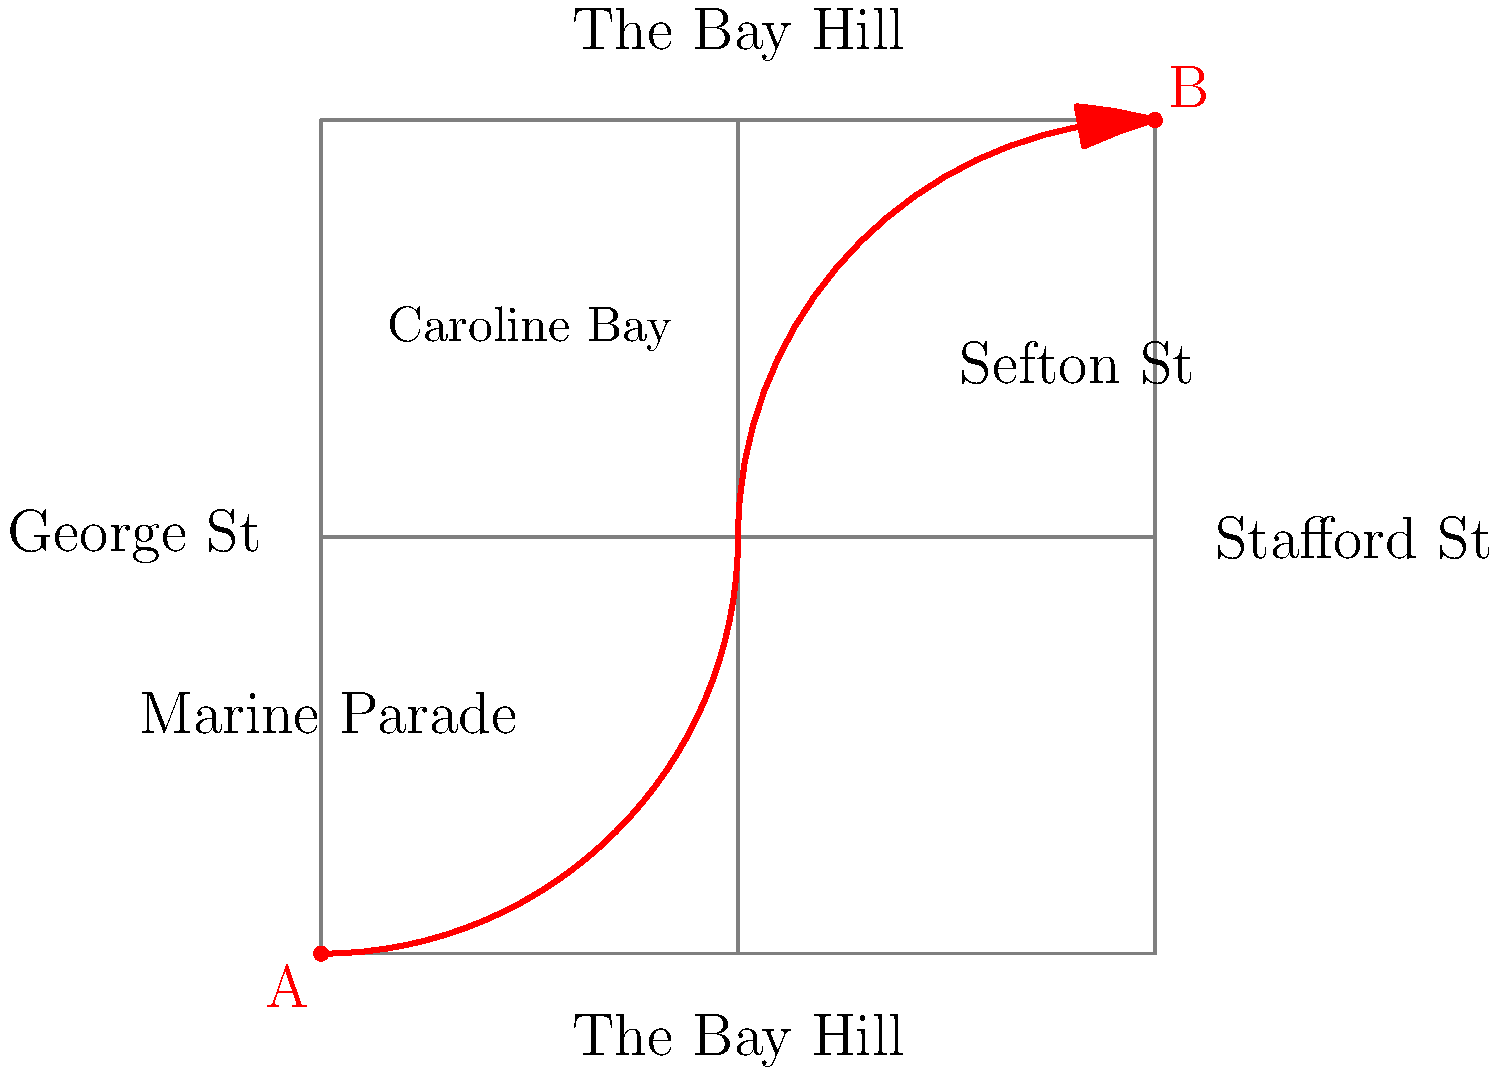As a local historian, you're asked to describe the Caroline Bay Carnival parade route on this simplified map of downtown Timaru. The parade starts at point A and ends at point B. Which two main streets does the parade route primarily follow, and in what order? To answer this question, we need to carefully examine the provided map and trace the parade route from point A to point B. Let's break it down step-by-step:

1. The parade starts at point A, which is located at the bottom-left corner of the map.
2. From point A, the route moves eastward along the street labeled "The Bay Hill" at the bottom of the map.
3. At the intersection with "Stafford St", the route turns northward and continues along Stafford St.
4. The parade continues north on Stafford St until it reaches point B at the top-right corner of the map, where it intersects with the upper street also labeled "The Bay Hill".

Therefore, the parade primarily follows two main streets:
1. The Bay Hill (lower portion of the map)
2. Stafford St

The order in which these streets are followed is crucial. The parade first moves along The Bay Hill, then turns onto Stafford St.
Answer: The Bay Hill, then Stafford St 